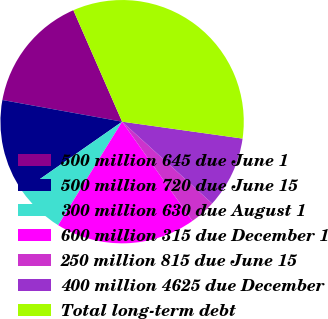Convert chart to OTSL. <chart><loc_0><loc_0><loc_500><loc_500><pie_chart><fcel>500 million 645 due June 1<fcel>500 million 720 due June 15<fcel>300 million 630 due August 1<fcel>600 million 315 due December 1<fcel>250 million 815 due June 15<fcel>400 million 4625 due December<fcel>Total long-term debt<nl><fcel>15.59%<fcel>12.55%<fcel>6.49%<fcel>18.62%<fcel>3.45%<fcel>9.52%<fcel>33.78%<nl></chart> 